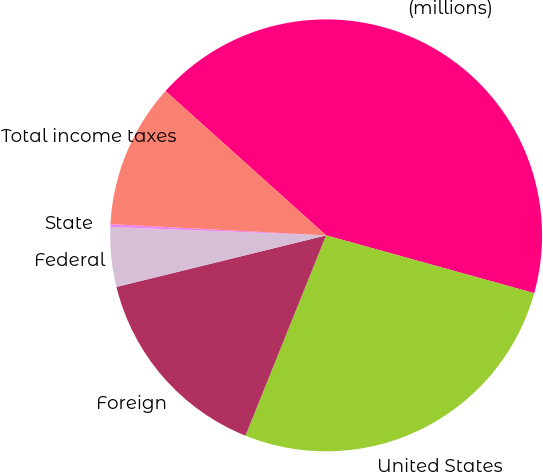Convert chart. <chart><loc_0><loc_0><loc_500><loc_500><pie_chart><fcel>(millions)<fcel>United States<fcel>Foreign<fcel>Federal<fcel>State<fcel>Total income taxes<nl><fcel>42.66%<fcel>26.78%<fcel>15.07%<fcel>4.46%<fcel>0.21%<fcel>10.82%<nl></chart> 